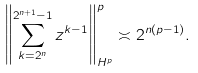<formula> <loc_0><loc_0><loc_500><loc_500>\left \| \sum _ { k = 2 ^ { n } } ^ { 2 ^ { n + 1 } - 1 } z ^ { k - 1 } \right \| ^ { p } _ { H ^ { p } } \asymp 2 ^ { n ( p - 1 ) } .</formula> 